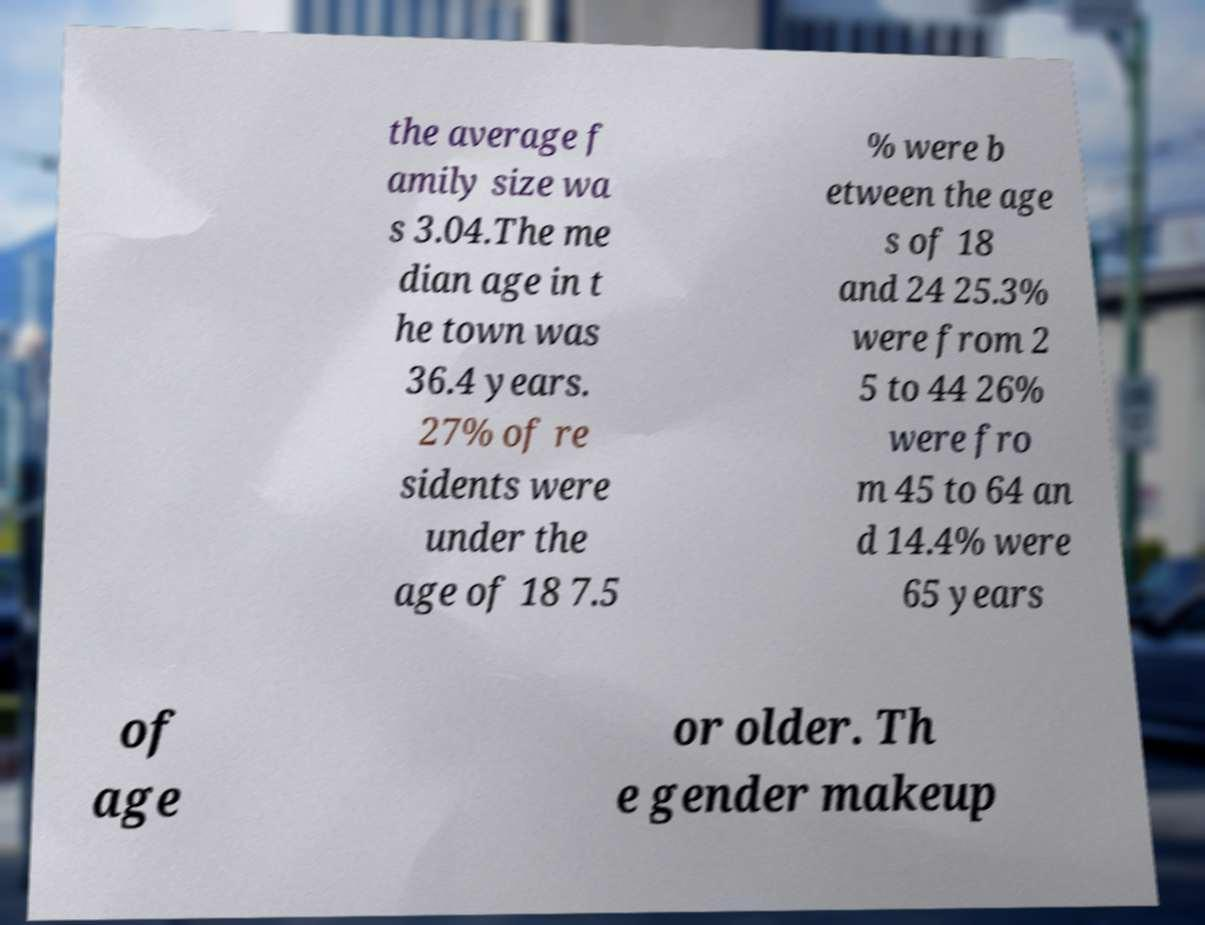Can you accurately transcribe the text from the provided image for me? the average f amily size wa s 3.04.The me dian age in t he town was 36.4 years. 27% of re sidents were under the age of 18 7.5 % were b etween the age s of 18 and 24 25.3% were from 2 5 to 44 26% were fro m 45 to 64 an d 14.4% were 65 years of age or older. Th e gender makeup 